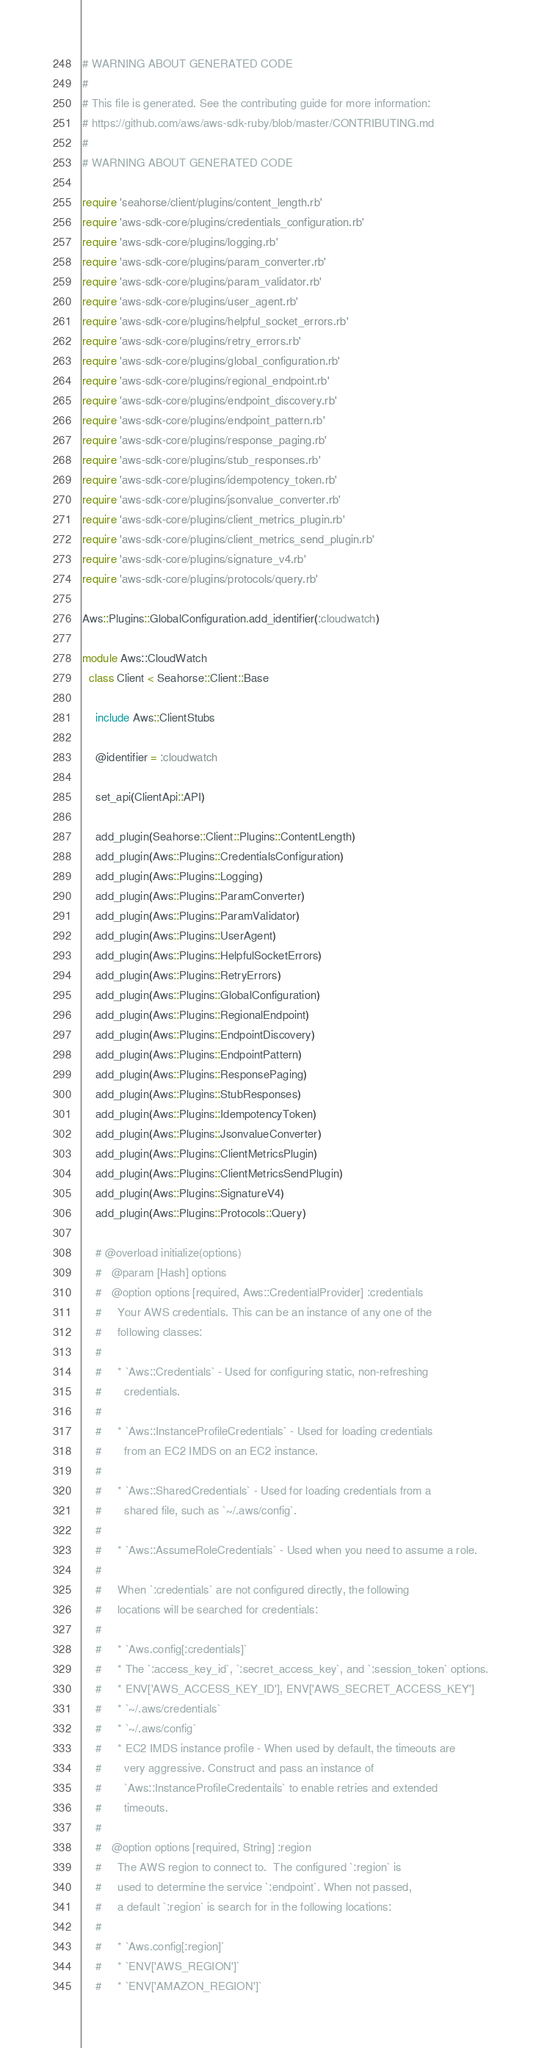Convert code to text. <code><loc_0><loc_0><loc_500><loc_500><_Ruby_># WARNING ABOUT GENERATED CODE
#
# This file is generated. See the contributing guide for more information:
# https://github.com/aws/aws-sdk-ruby/blob/master/CONTRIBUTING.md
#
# WARNING ABOUT GENERATED CODE

require 'seahorse/client/plugins/content_length.rb'
require 'aws-sdk-core/plugins/credentials_configuration.rb'
require 'aws-sdk-core/plugins/logging.rb'
require 'aws-sdk-core/plugins/param_converter.rb'
require 'aws-sdk-core/plugins/param_validator.rb'
require 'aws-sdk-core/plugins/user_agent.rb'
require 'aws-sdk-core/plugins/helpful_socket_errors.rb'
require 'aws-sdk-core/plugins/retry_errors.rb'
require 'aws-sdk-core/plugins/global_configuration.rb'
require 'aws-sdk-core/plugins/regional_endpoint.rb'
require 'aws-sdk-core/plugins/endpoint_discovery.rb'
require 'aws-sdk-core/plugins/endpoint_pattern.rb'
require 'aws-sdk-core/plugins/response_paging.rb'
require 'aws-sdk-core/plugins/stub_responses.rb'
require 'aws-sdk-core/plugins/idempotency_token.rb'
require 'aws-sdk-core/plugins/jsonvalue_converter.rb'
require 'aws-sdk-core/plugins/client_metrics_plugin.rb'
require 'aws-sdk-core/plugins/client_metrics_send_plugin.rb'
require 'aws-sdk-core/plugins/signature_v4.rb'
require 'aws-sdk-core/plugins/protocols/query.rb'

Aws::Plugins::GlobalConfiguration.add_identifier(:cloudwatch)

module Aws::CloudWatch
  class Client < Seahorse::Client::Base

    include Aws::ClientStubs

    @identifier = :cloudwatch

    set_api(ClientApi::API)

    add_plugin(Seahorse::Client::Plugins::ContentLength)
    add_plugin(Aws::Plugins::CredentialsConfiguration)
    add_plugin(Aws::Plugins::Logging)
    add_plugin(Aws::Plugins::ParamConverter)
    add_plugin(Aws::Plugins::ParamValidator)
    add_plugin(Aws::Plugins::UserAgent)
    add_plugin(Aws::Plugins::HelpfulSocketErrors)
    add_plugin(Aws::Plugins::RetryErrors)
    add_plugin(Aws::Plugins::GlobalConfiguration)
    add_plugin(Aws::Plugins::RegionalEndpoint)
    add_plugin(Aws::Plugins::EndpointDiscovery)
    add_plugin(Aws::Plugins::EndpointPattern)
    add_plugin(Aws::Plugins::ResponsePaging)
    add_plugin(Aws::Plugins::StubResponses)
    add_plugin(Aws::Plugins::IdempotencyToken)
    add_plugin(Aws::Plugins::JsonvalueConverter)
    add_plugin(Aws::Plugins::ClientMetricsPlugin)
    add_plugin(Aws::Plugins::ClientMetricsSendPlugin)
    add_plugin(Aws::Plugins::SignatureV4)
    add_plugin(Aws::Plugins::Protocols::Query)

    # @overload initialize(options)
    #   @param [Hash] options
    #   @option options [required, Aws::CredentialProvider] :credentials
    #     Your AWS credentials. This can be an instance of any one of the
    #     following classes:
    #
    #     * `Aws::Credentials` - Used for configuring static, non-refreshing
    #       credentials.
    #
    #     * `Aws::InstanceProfileCredentials` - Used for loading credentials
    #       from an EC2 IMDS on an EC2 instance.
    #
    #     * `Aws::SharedCredentials` - Used for loading credentials from a
    #       shared file, such as `~/.aws/config`.
    #
    #     * `Aws::AssumeRoleCredentials` - Used when you need to assume a role.
    #
    #     When `:credentials` are not configured directly, the following
    #     locations will be searched for credentials:
    #
    #     * `Aws.config[:credentials]`
    #     * The `:access_key_id`, `:secret_access_key`, and `:session_token` options.
    #     * ENV['AWS_ACCESS_KEY_ID'], ENV['AWS_SECRET_ACCESS_KEY']
    #     * `~/.aws/credentials`
    #     * `~/.aws/config`
    #     * EC2 IMDS instance profile - When used by default, the timeouts are
    #       very aggressive. Construct and pass an instance of
    #       `Aws::InstanceProfileCredentails` to enable retries and extended
    #       timeouts.
    #
    #   @option options [required, String] :region
    #     The AWS region to connect to.  The configured `:region` is
    #     used to determine the service `:endpoint`. When not passed,
    #     a default `:region` is search for in the following locations:
    #
    #     * `Aws.config[:region]`
    #     * `ENV['AWS_REGION']`
    #     * `ENV['AMAZON_REGION']`</code> 